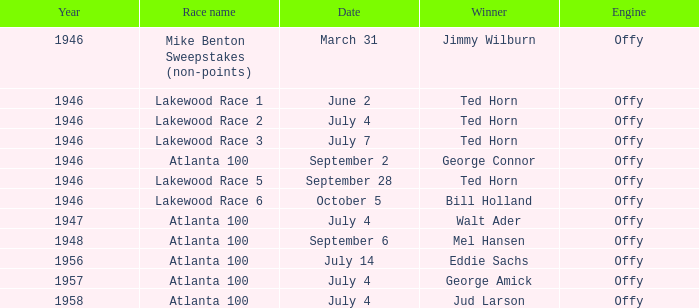Which race did Bill Holland win in 1946? Lakewood Race 6. 